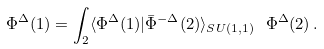<formula> <loc_0><loc_0><loc_500><loc_500>\Phi ^ { \Delta } ( 1 ) = \int _ { 2 } \langle \Phi ^ { \Delta } ( 1 ) | \bar { \Phi } ^ { - \Delta } ( 2 ) \rangle _ { S U ( 1 , 1 ) } \ \Phi ^ { \Delta } ( 2 ) \, .</formula> 